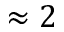Convert formula to latex. <formula><loc_0><loc_0><loc_500><loc_500>\approx 2</formula> 